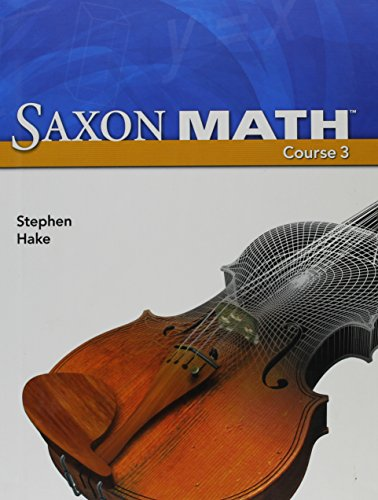Why is there an image of a violin on the cover of a math textbook? The violin image might be used to symbolize the harmony and precision in mathematics, similar to the careful skill and practice required in music. 